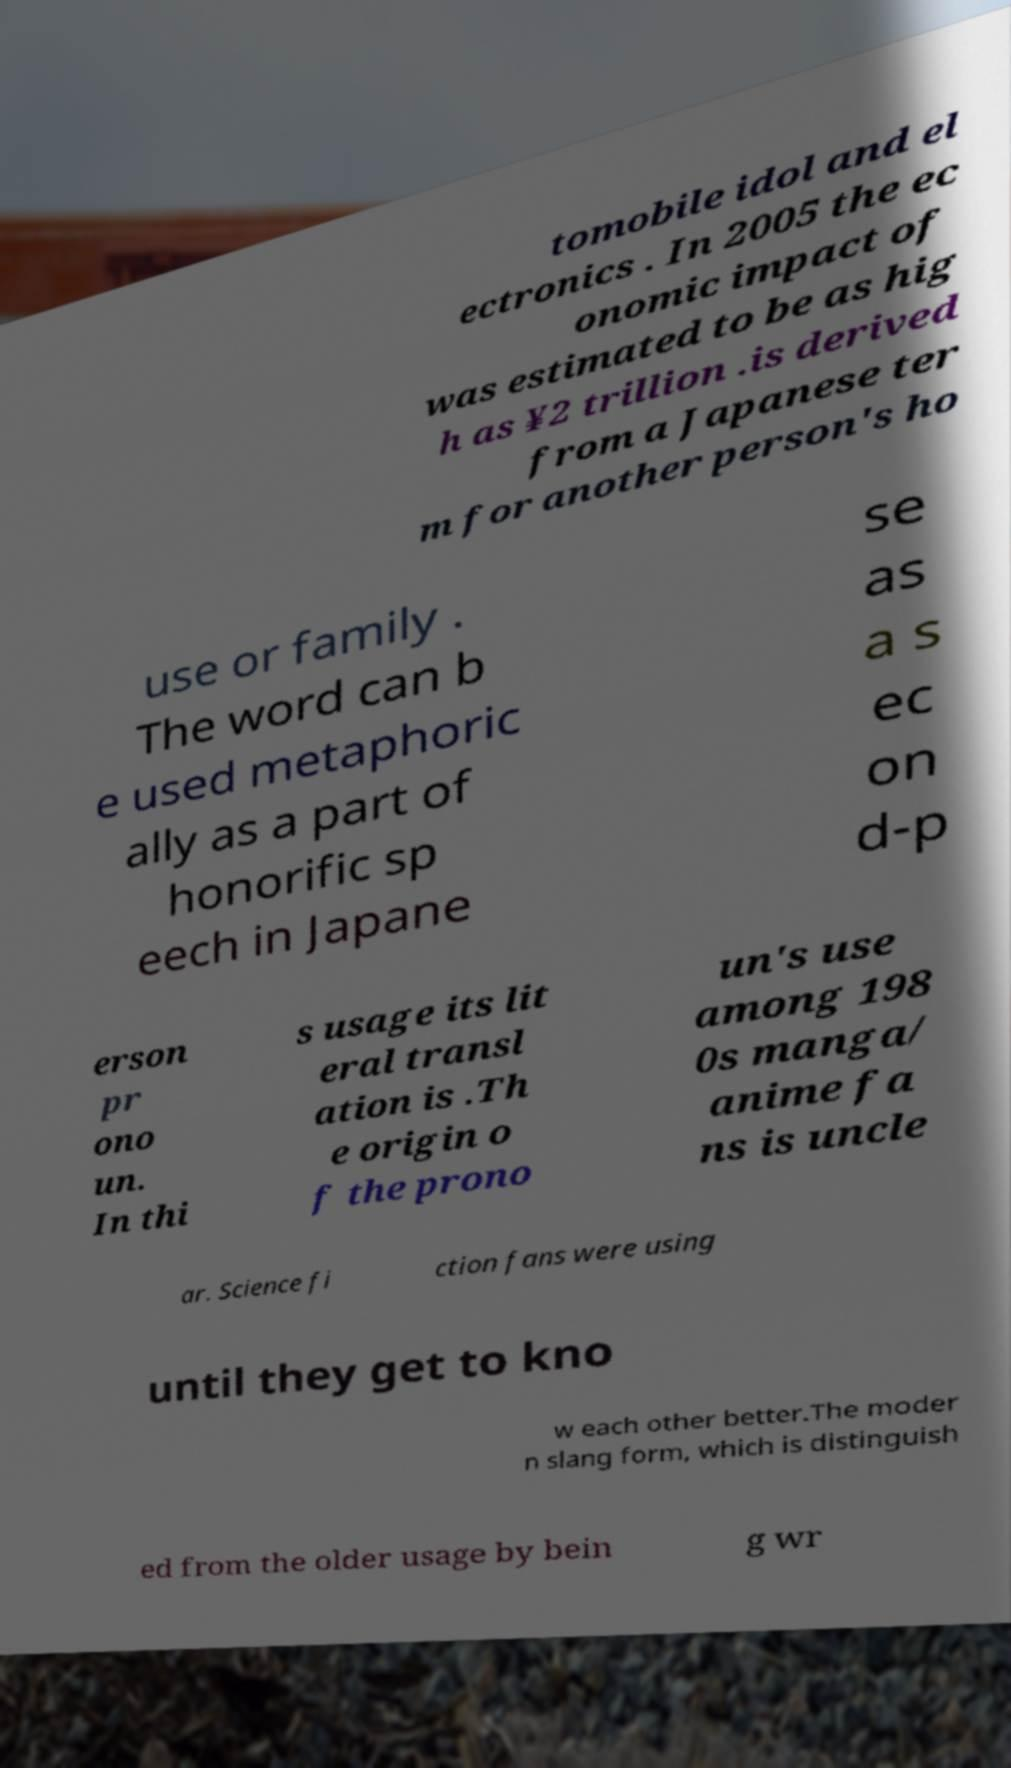Could you extract and type out the text from this image? tomobile idol and el ectronics . In 2005 the ec onomic impact of was estimated to be as hig h as ¥2 trillion .is derived from a Japanese ter m for another person's ho use or family . The word can b e used metaphoric ally as a part of honorific sp eech in Japane se as a s ec on d-p erson pr ono un. In thi s usage its lit eral transl ation is .Th e origin o f the prono un's use among 198 0s manga/ anime fa ns is uncle ar. Science fi ction fans were using until they get to kno w each other better.The moder n slang form, which is distinguish ed from the older usage by bein g wr 